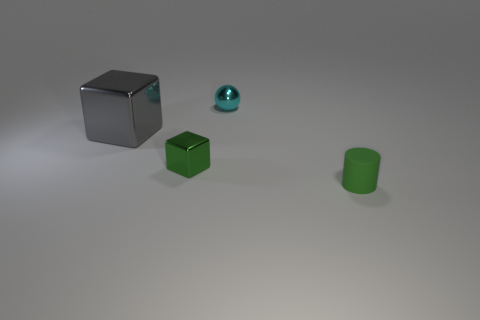The tiny thing that is the same color as the matte cylinder is what shape?
Your answer should be compact. Cube. Are there any purple shiny cubes?
Offer a terse response. No. There is a metallic object that is in front of the gray metallic thing; what shape is it?
Provide a succinct answer. Cube. What number of objects are both to the right of the gray metal cube and behind the small matte cylinder?
Keep it short and to the point. 2. Are there any big yellow things that have the same material as the tiny cyan ball?
Ensure brevity in your answer.  No. What is the size of the matte cylinder that is the same color as the small block?
Keep it short and to the point. Small. What number of blocks are either tiny objects or gray metallic objects?
Offer a very short reply. 2. What is the size of the gray metallic block?
Offer a very short reply. Large. How many small metal things are behind the tiny green metal thing?
Offer a very short reply. 1. What size is the green object behind the green object right of the small metal ball?
Offer a very short reply. Small. 